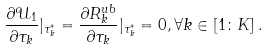<formula> <loc_0><loc_0><loc_500><loc_500>\frac { \partial { \mathcal { U } } _ { 1 } } { \partial \tau _ { k } } | _ { \tau ^ { * } _ { k } } = \frac { \partial R ^ { u b } _ { k } } { \partial \tau _ { k } } | _ { \tau ^ { * } _ { k } } = 0 , \forall k \in \left [ 1 \colon K \right ] .</formula> 